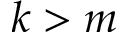<formula> <loc_0><loc_0><loc_500><loc_500>k > m</formula> 